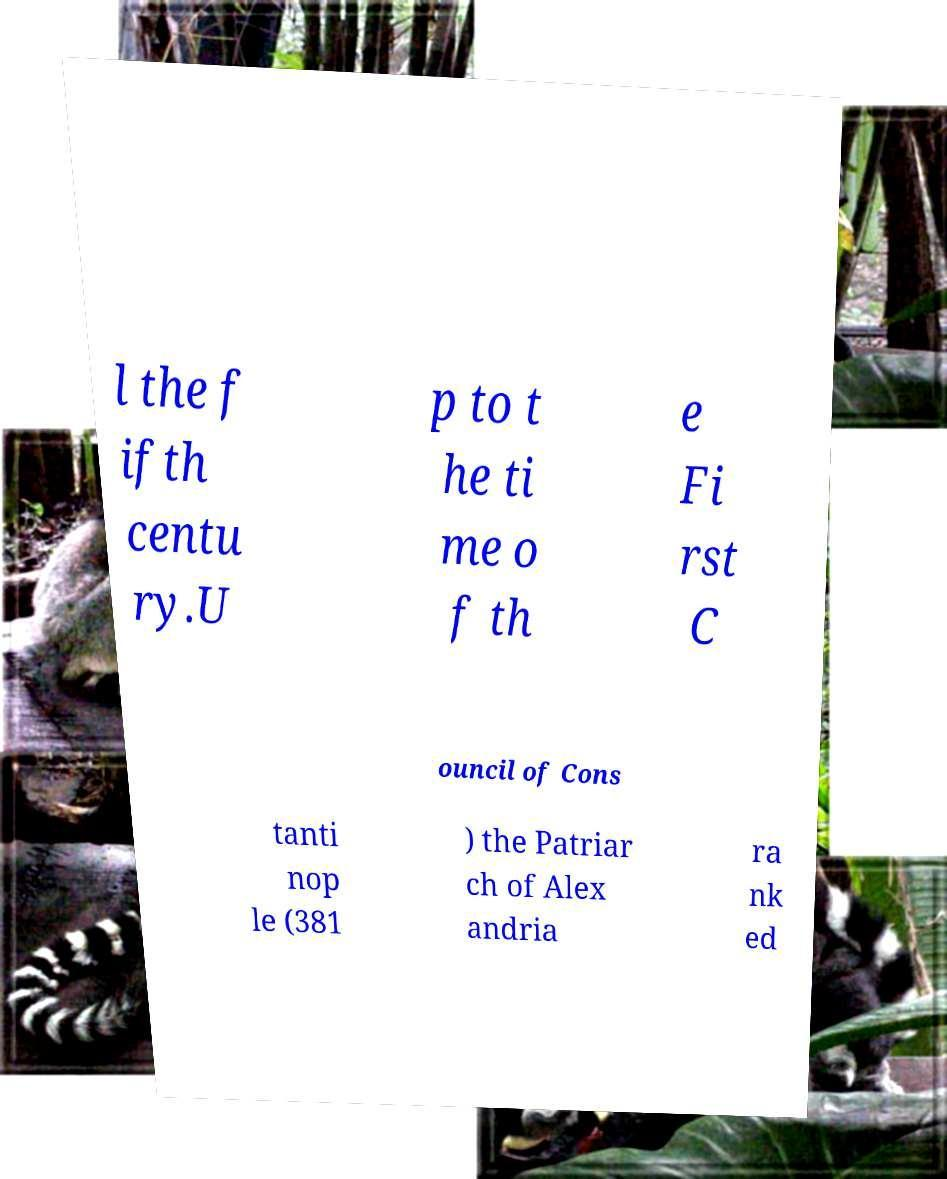For documentation purposes, I need the text within this image transcribed. Could you provide that? l the f ifth centu ry.U p to t he ti me o f th e Fi rst C ouncil of Cons tanti nop le (381 ) the Patriar ch of Alex andria ra nk ed 